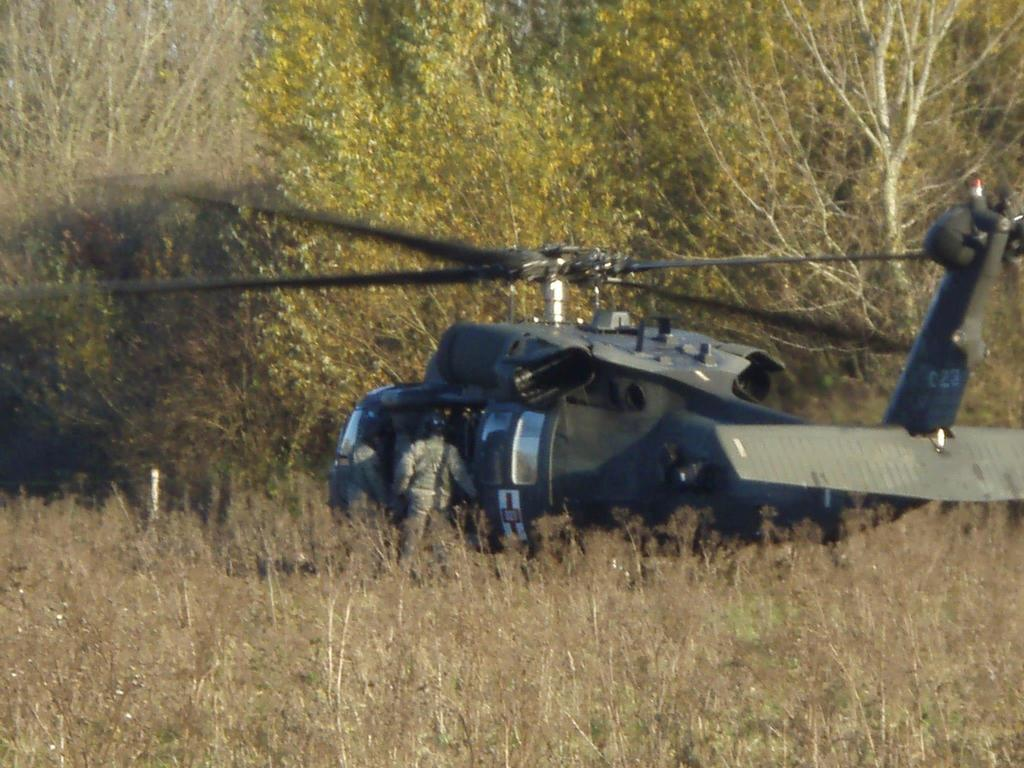What is the main subject of the image? The main subject of the image is an aircraft. Can you describe the aircraft in the image? The aircraft is blue. How many people are in the image? There are two persons in the image. What are the persons wearing? The persons are wearing military dresses. What can be seen in the background of the image? There are trees in the background of the image. What is the color of the trees? The trees are green. What type of relation does the turkey have with the aircraft in the image? There is no turkey present in the image, so it is not possible to determine any relation it might have with the aircraft. Can you describe the snake that is coiled around the aircraft in the image? There is no snake present in the image; the aircraft is not coiled around anything. 